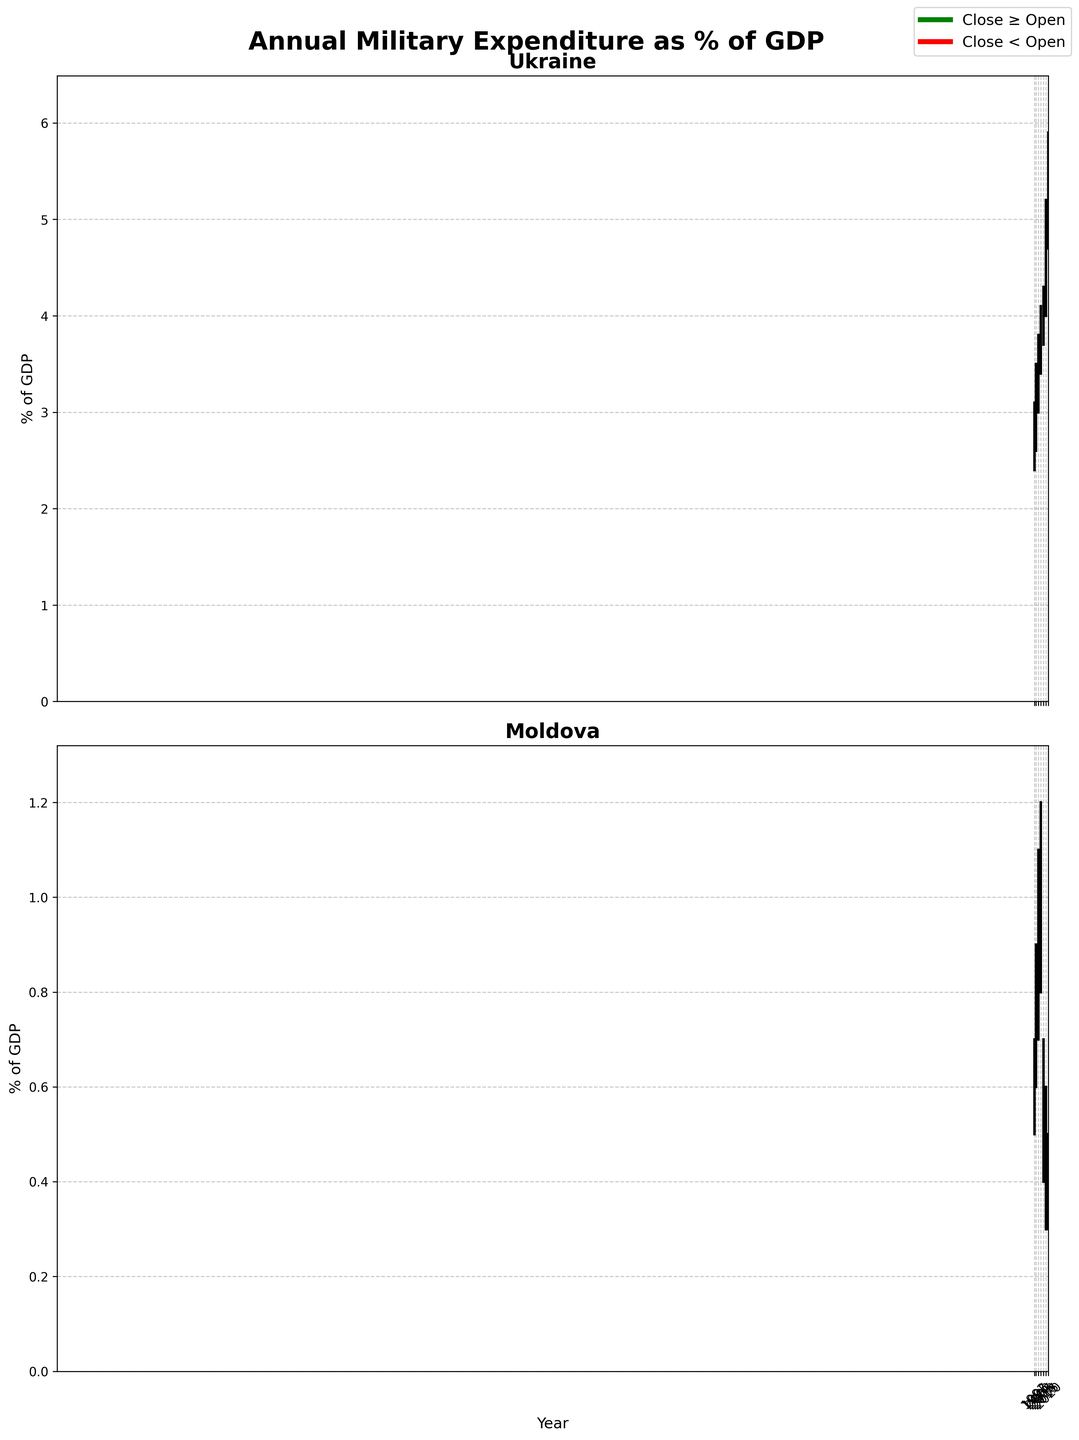What is the title of the figure? The title of the figure is presented at the top in bold text. It reads "Annual Military Expenditure as % of GDP."
Answer: Annual Military Expenditure as % of GDP Which country had a higher military expenditure as a percentage of GDP in 2020? Comparing the closing values for 2020, Ukraine has a closing value of 5.4% while Moldova has a closing value of 0.4%. Therefore, Ukraine had a higher military expenditure as a percentage of GDP in 2020.
Answer: Ukraine For which years did Ukraine's military expenditure as a percentage of GDP close higher than it opened? Observing the bars for Ukraine, the green bars represent cases where the close value is higher than the open value: 1992, 1995, 2010, 2015, 2020.
Answer: 1992, 1995, 2010, 2015, 2020 What was the highest military expenditure as a percentage of GDP for Moldova, and in which year did it occur? The highest value on the y-axis for Moldova’s chart is noted at the top line of the OHLC bar. In 2005, Moldova's highest value reached 1.2%.
Answer: 1.2% in 2005 During which year did Ukraine have the maximum difference between its high and low values? The difference between high and low values is the largest in 2015 (5.2% - 4.0% = 1.2%).
Answer: 2015 How did the military expenditure trend for Moldova change between 2005 and 2010? From 2005 to 2010, Moldova's military expenditure decreased, with the close value dropping from 1.0% in 2005 to 0.6% in 2010.
Answer: Decreased By how much percentage did Ukraine's military expenditure as a percentage of GDP change from the Opening to Closing value in 2020? The change is calculated as: 5.4% (Close) - 4.8% (Open) = 0.6%.
Answer: 0.6% Which country had a decrease in its military expenditure as a percentage of GDP in the majority of the periods shown? Moldova shows more instances of red bars (1992, 2010, 2015, 2020) indicating a decrease in the military expenditure for most periods compared to Ukraine.
Answer: Moldova 